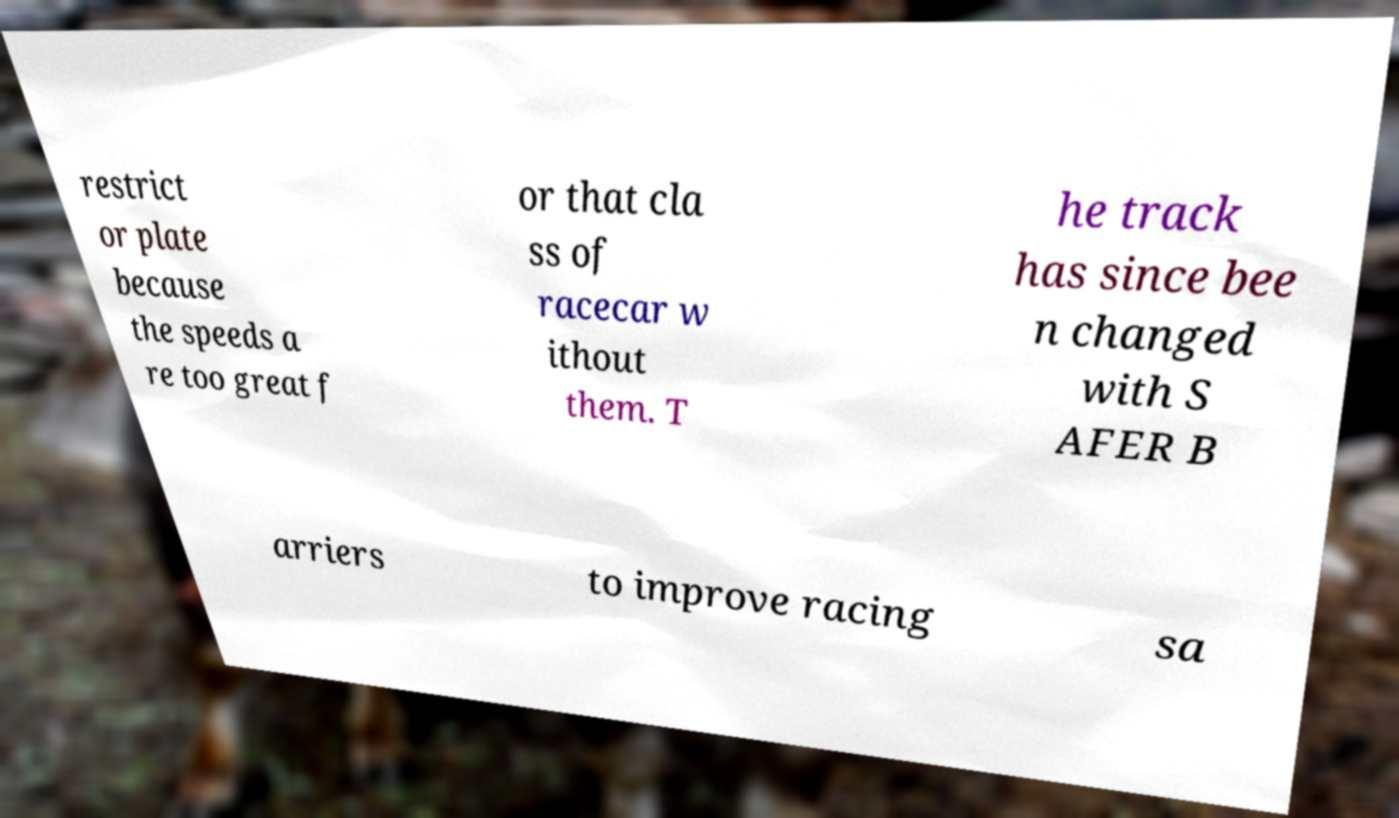I need the written content from this picture converted into text. Can you do that? restrict or plate because the speeds a re too great f or that cla ss of racecar w ithout them. T he track has since bee n changed with S AFER B arriers to improve racing sa 